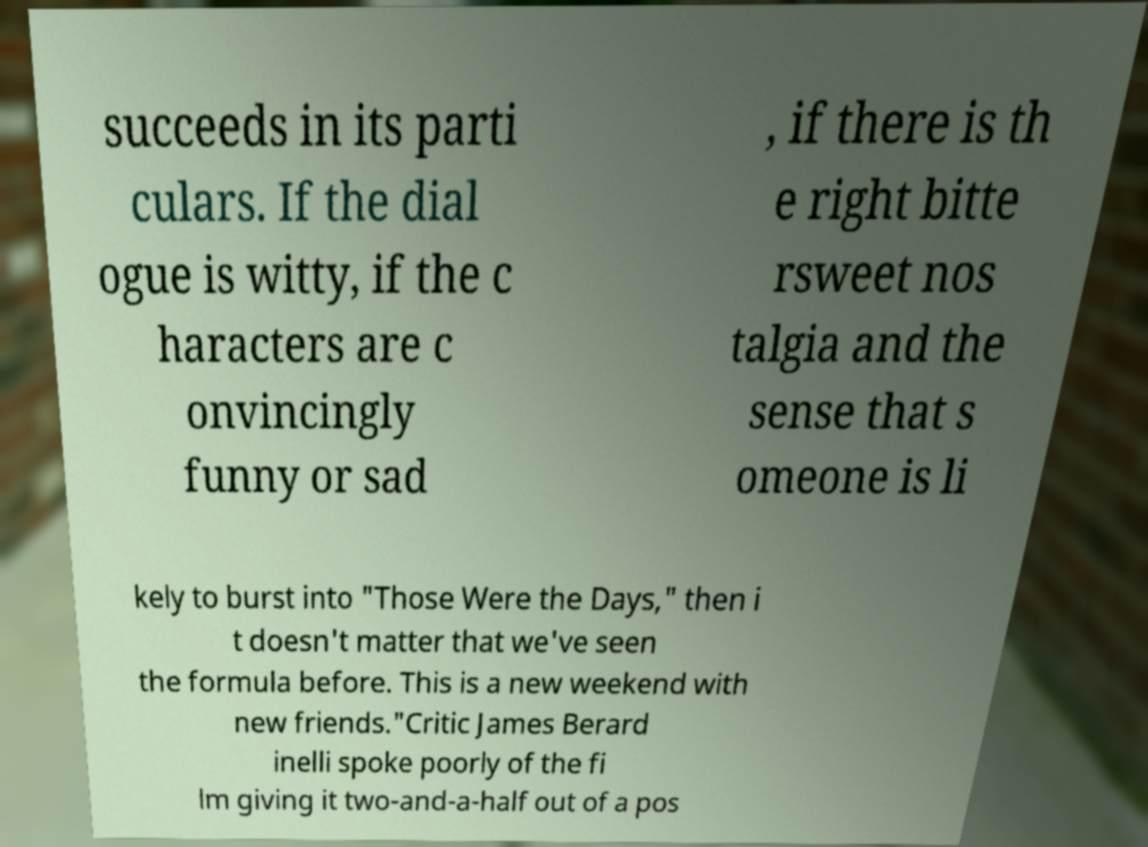There's text embedded in this image that I need extracted. Can you transcribe it verbatim? succeeds in its parti culars. If the dial ogue is witty, if the c haracters are c onvincingly funny or sad , if there is th e right bitte rsweet nos talgia and the sense that s omeone is li kely to burst into "Those Were the Days," then i t doesn't matter that we've seen the formula before. This is a new weekend with new friends."Critic James Berard inelli spoke poorly of the fi lm giving it two-and-a-half out of a pos 